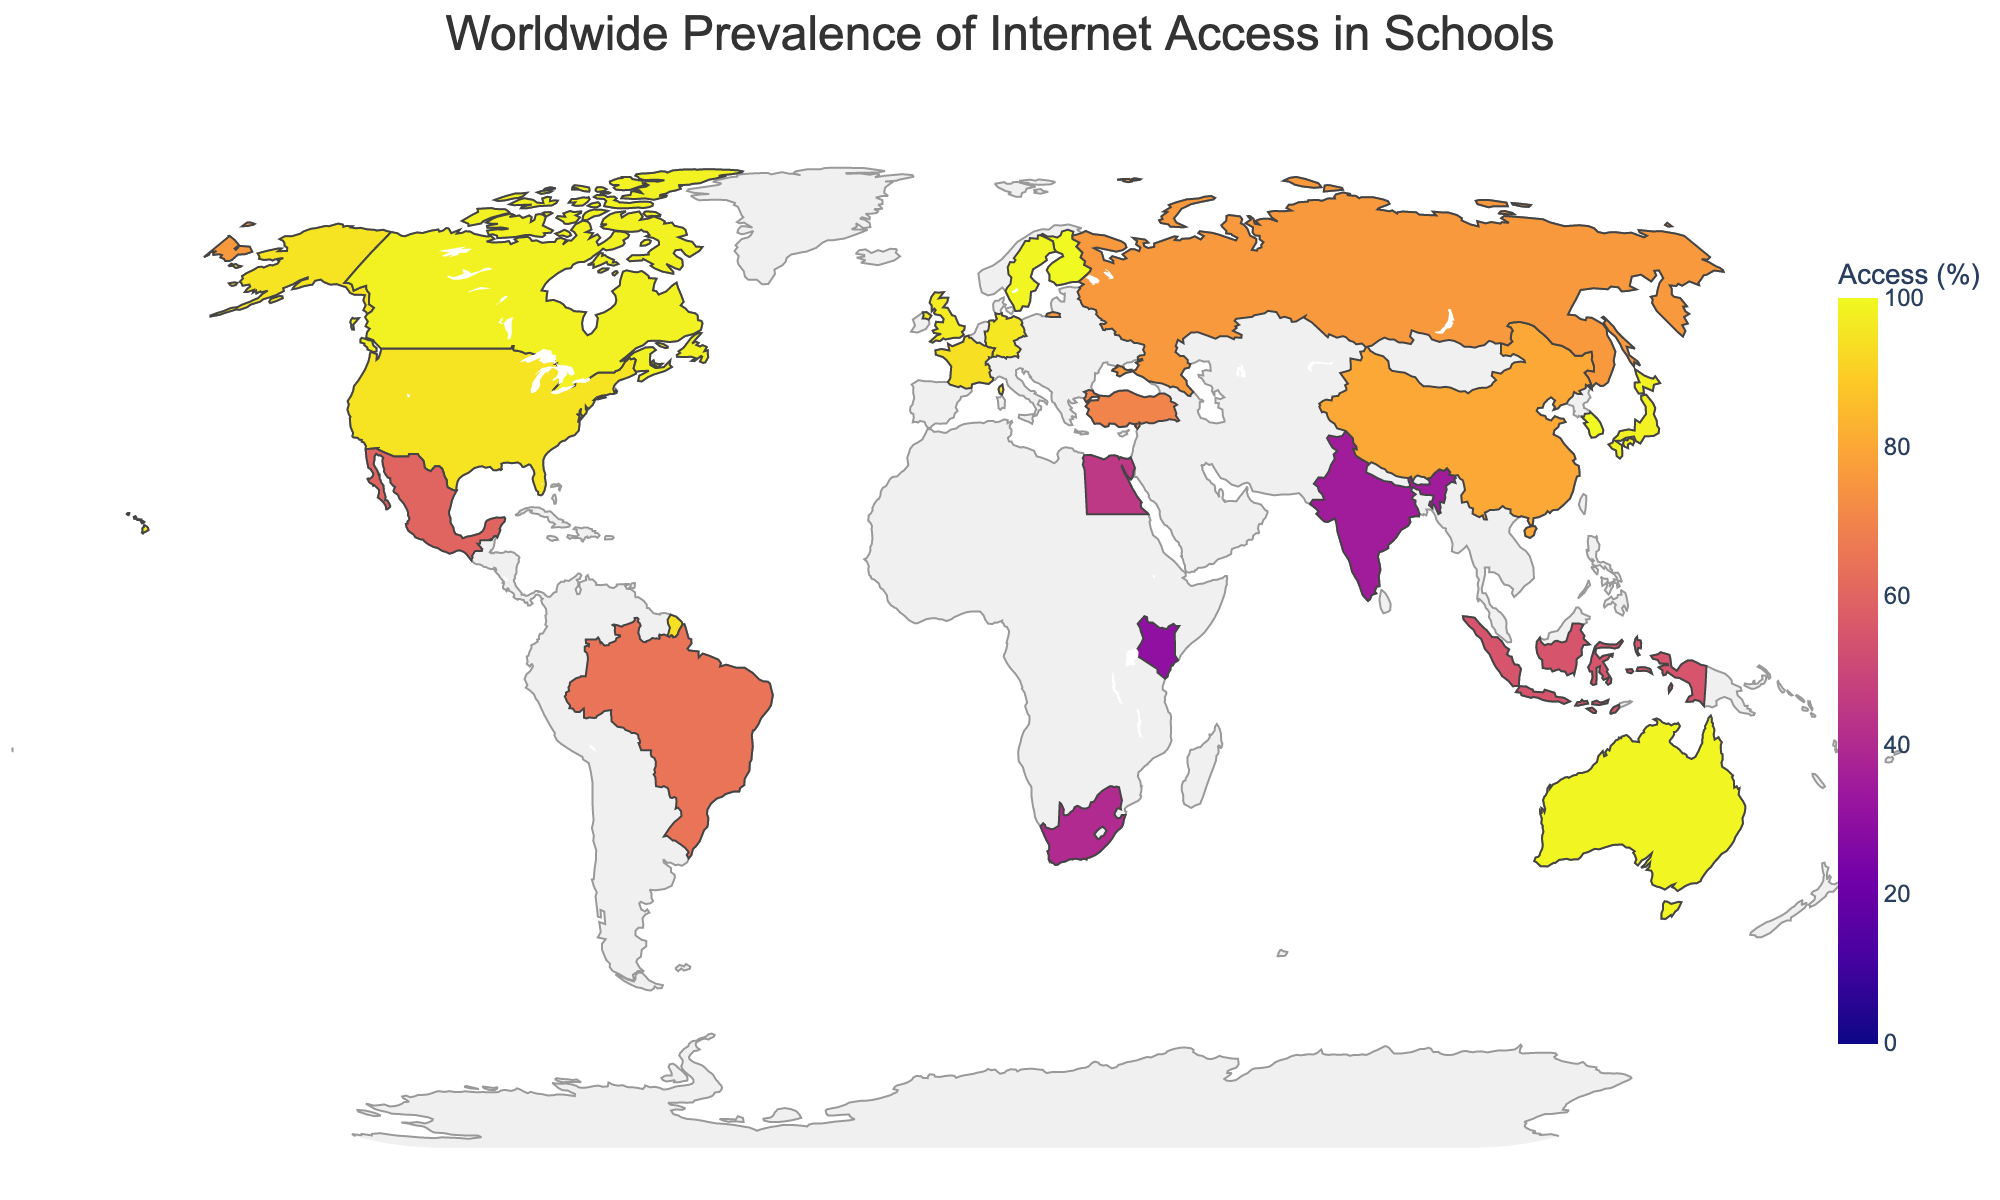What's the title of the geographic plot? The title of the plot is usually displayed prominently at the top. By looking at the top center of the figure, the title "Worldwide Prevalence of Internet Access in Schools" is visible.
Answer: Worldwide Prevalence of Internet Access in Schools Which countries have 100% internet access in schools? By looking at the color scale and matching the countries that are in the darkest color (representing 100%), we can identify the countries. The names of these countries can also be verified through the hover information when you place your cursor over the countries.
Answer: Finland, South Korea Which country has the lowest internet access in schools and what is its percentage? By referring to the lightest color on the plot that represents the lowest access value, and verifying it through the hover information, we identify that Kenya has the lowest percentage.
Answer: Kenya, 30% What is the range of internet access percentages depicted on the plot? The color scale on the right side of the plot shows the range of internet access percentages from 0% to 100%.
Answer: 0% to 100% What's the average internet access percentage for all the countries shown in the plot? Sum all the individual percentages and then divide by the number of countries. (95+100+100+98+96+97+94+99+98+99+65+35+80+76+40+30+60+70+45+55) / 20 = 68.55
Answer: 68.55% Which continent seems to have the highest average internet access in schools? By visually estimating the concentrations of darker colors (higher access percentages) on the continents, it's apparent that Europe has the highest average internet access based on the dark colors visible across multiple countries.
Answer: Europe Compare the internet access percentage between the United States and China. Which has a higher percentage? By identifying the colors assigned to the United States and China and linking them to the values shown, the United States has a darker color indicating 95%, while China is lighter indicating 80%.
Answer: United States How many countries have internet access in schools at or above 90%? Count the number of countries that appear in the darkest color shades (90% and above) based on the color scale and/or hover information.
Answer: 9 What's the difference in percentage points between Finland and India in terms of internet access in schools? Subtract the percentage of India from that of Finland. 100% - 35% = 65 percentage points.
Answer: 65 percentage points 